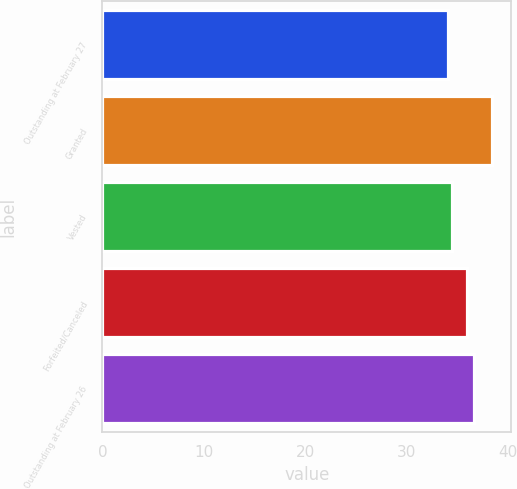Convert chart to OTSL. <chart><loc_0><loc_0><loc_500><loc_500><bar_chart><fcel>Outstanding at February 27<fcel>Granted<fcel>Vested<fcel>Forfeited/Canceled<fcel>Outstanding at February 26<nl><fcel>34.06<fcel>38.4<fcel>34.49<fcel>35.93<fcel>36.6<nl></chart> 